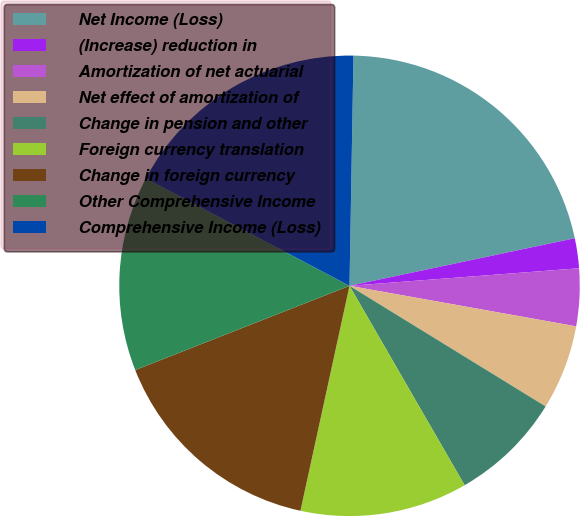Convert chart to OTSL. <chart><loc_0><loc_0><loc_500><loc_500><pie_chart><fcel>Net Income (Loss)<fcel>(Increase) reduction in<fcel>Amortization of net actuarial<fcel>Net effect of amortization of<fcel>Change in pension and other<fcel>Foreign currency translation<fcel>Change in foreign currency<fcel>Other Comprehensive Income<fcel>Comprehensive Income (Loss)<nl><fcel>21.41%<fcel>2.1%<fcel>4.03%<fcel>5.96%<fcel>7.89%<fcel>11.75%<fcel>15.62%<fcel>13.68%<fcel>17.55%<nl></chart> 